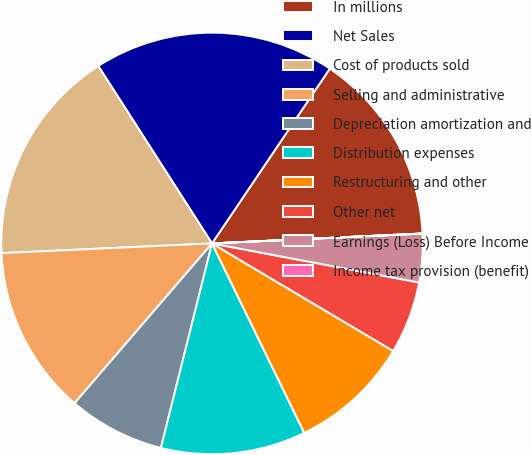<chart> <loc_0><loc_0><loc_500><loc_500><pie_chart><fcel>In millions<fcel>Net Sales<fcel>Cost of products sold<fcel>Selling and administrative<fcel>Depreciation amortization and<fcel>Distribution expenses<fcel>Restructuring and other<fcel>Other net<fcel>Earnings (Loss) Before Income<fcel>Income tax provision (benefit)<nl><fcel>14.81%<fcel>18.51%<fcel>16.66%<fcel>12.96%<fcel>7.41%<fcel>11.11%<fcel>9.26%<fcel>5.56%<fcel>3.71%<fcel>0.01%<nl></chart> 